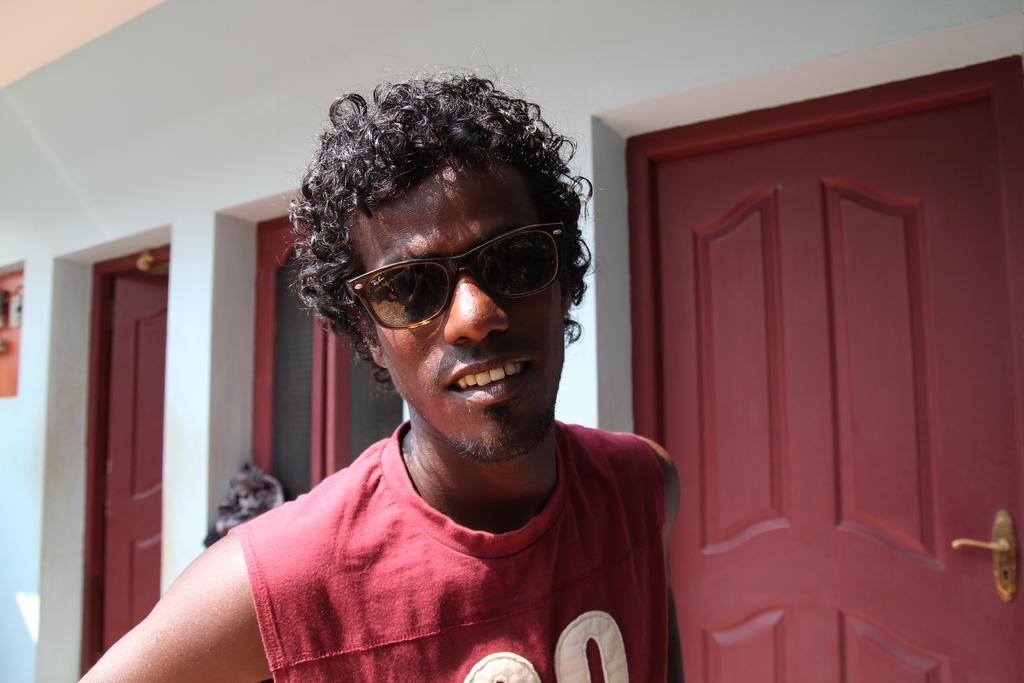Could you give a brief overview of what you see in this image? In the front of the image I can see a person wore goggles. In the background of the image there are doors, window and walls.   